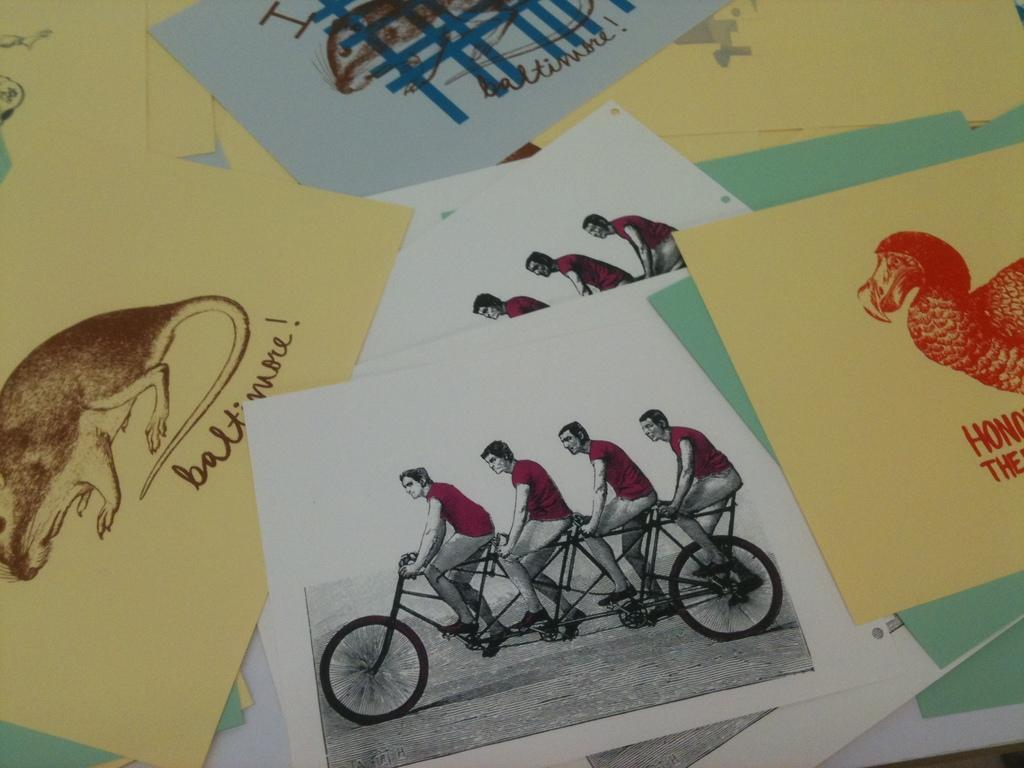What type of artwork is depicted in the image? The image appears to contain sketches. What time of day is the fowl shown in the image? There are no fowl present in the image, as it only contains sketches. 